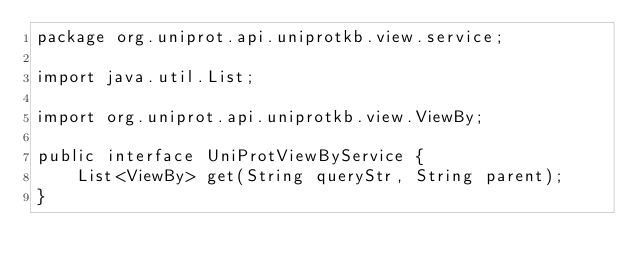Convert code to text. <code><loc_0><loc_0><loc_500><loc_500><_Java_>package org.uniprot.api.uniprotkb.view.service;

import java.util.List;

import org.uniprot.api.uniprotkb.view.ViewBy;

public interface UniProtViewByService {
    List<ViewBy> get(String queryStr, String parent);
}
</code> 